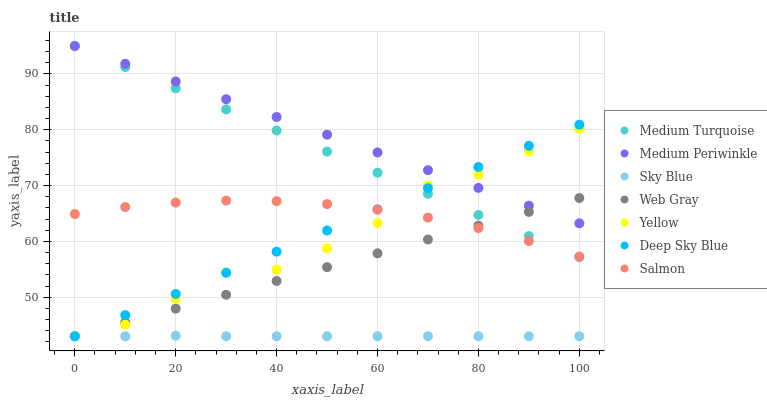Does Sky Blue have the minimum area under the curve?
Answer yes or no. Yes. Does Medium Periwinkle have the maximum area under the curve?
Answer yes or no. Yes. Does Deep Sky Blue have the minimum area under the curve?
Answer yes or no. No. Does Deep Sky Blue have the maximum area under the curve?
Answer yes or no. No. Is Deep Sky Blue the smoothest?
Answer yes or no. Yes. Is Yellow the roughest?
Answer yes or no. Yes. Is Salmon the smoothest?
Answer yes or no. No. Is Salmon the roughest?
Answer yes or no. No. Does Web Gray have the lowest value?
Answer yes or no. Yes. Does Salmon have the lowest value?
Answer yes or no. No. Does Medium Turquoise have the highest value?
Answer yes or no. Yes. Does Deep Sky Blue have the highest value?
Answer yes or no. No. Is Sky Blue less than Medium Turquoise?
Answer yes or no. Yes. Is Medium Turquoise greater than Sky Blue?
Answer yes or no. Yes. Does Deep Sky Blue intersect Yellow?
Answer yes or no. Yes. Is Deep Sky Blue less than Yellow?
Answer yes or no. No. Is Deep Sky Blue greater than Yellow?
Answer yes or no. No. Does Sky Blue intersect Medium Turquoise?
Answer yes or no. No. 